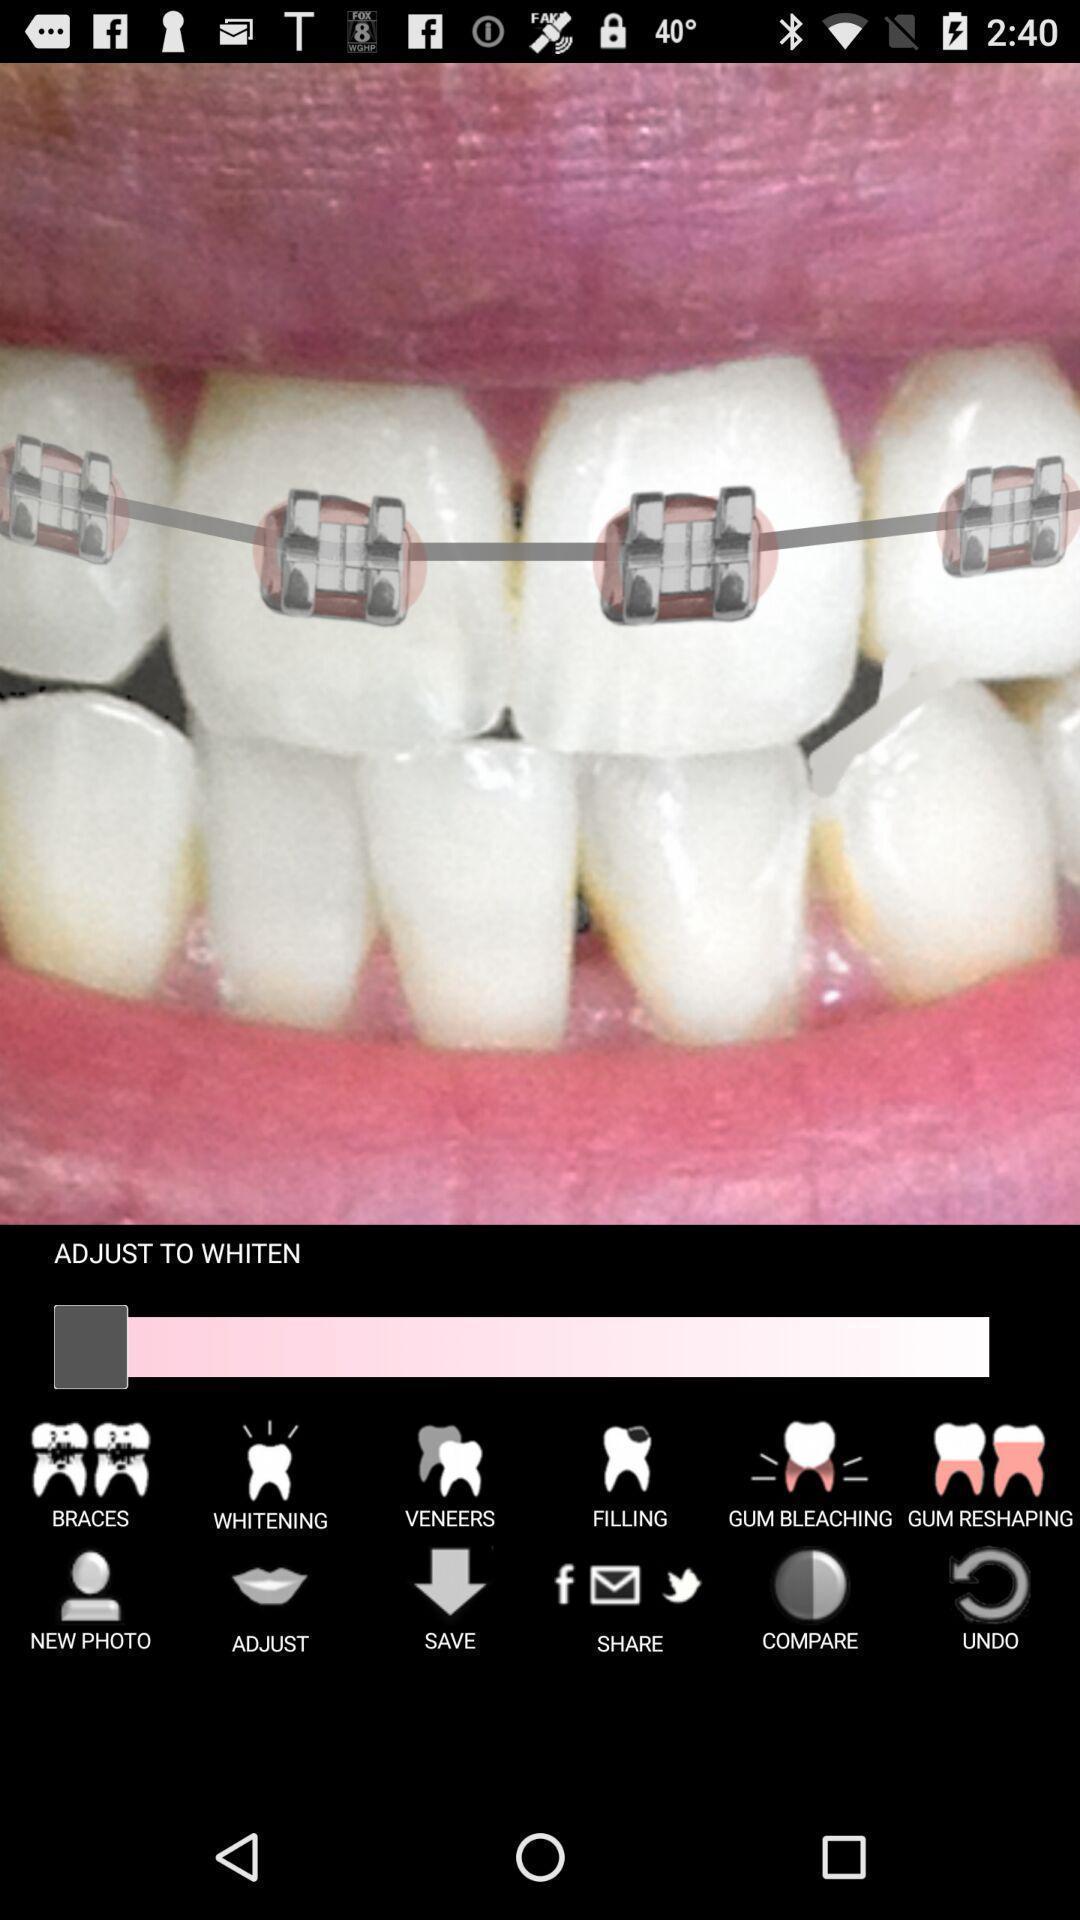Give me a summary of this screen capture. Screen showing the various option to edit image. 